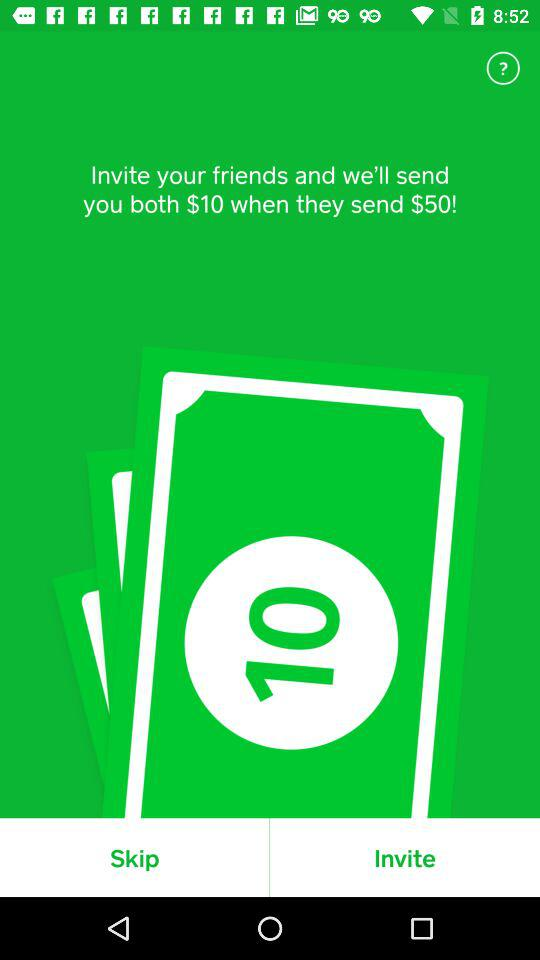How much more money will you receive if you invite your friend than if you don't?
Answer the question using a single word or phrase. $10 